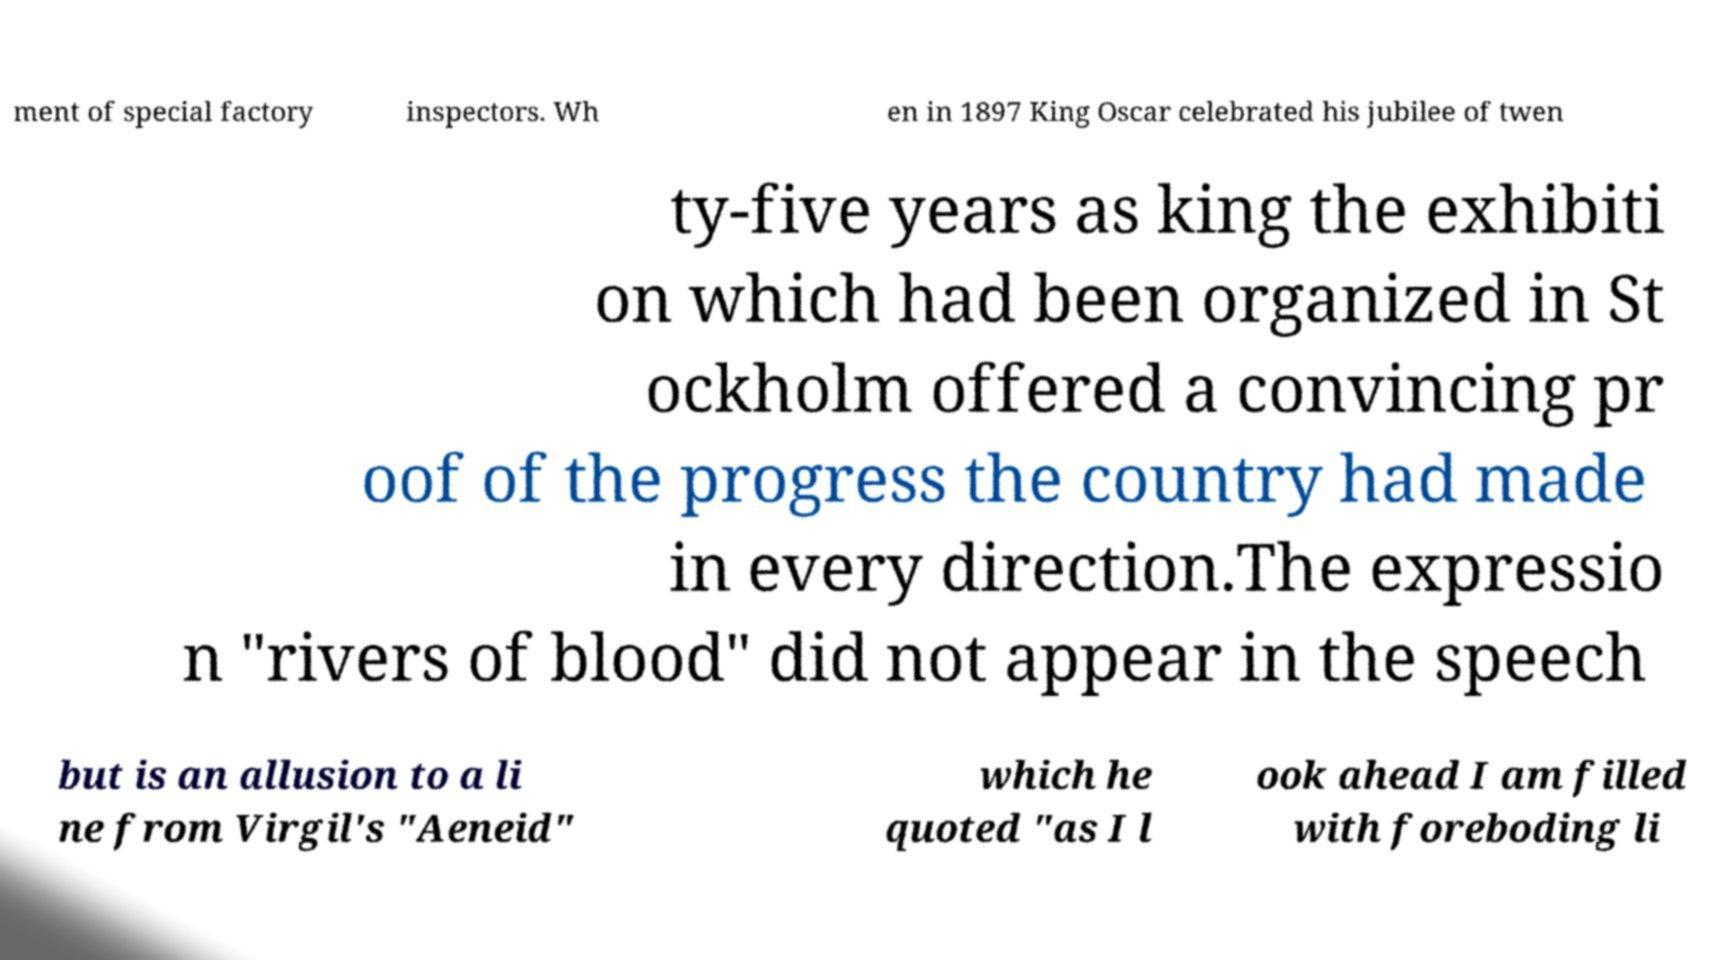I need the written content from this picture converted into text. Can you do that? ment of special factory inspectors. Wh en in 1897 King Oscar celebrated his jubilee of twen ty-five years as king the exhibiti on which had been organized in St ockholm offered a convincing pr oof of the progress the country had made in every direction.The expressio n "rivers of blood" did not appear in the speech but is an allusion to a li ne from Virgil's "Aeneid" which he quoted "as I l ook ahead I am filled with foreboding li 